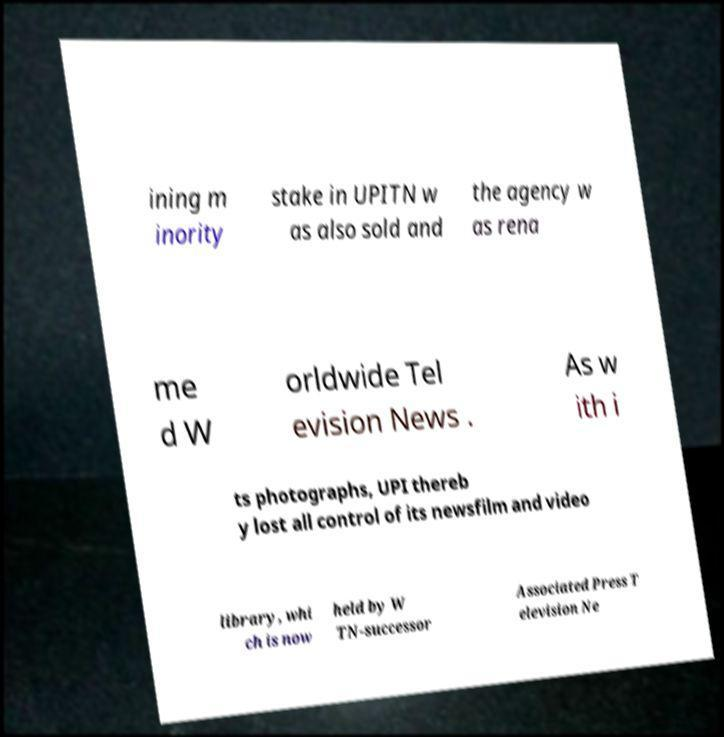Please identify and transcribe the text found in this image. ining m inority stake in UPITN w as also sold and the agency w as rena me d W orldwide Tel evision News . As w ith i ts photographs, UPI thereb y lost all control of its newsfilm and video library, whi ch is now held by W TN-successor Associated Press T elevision Ne 